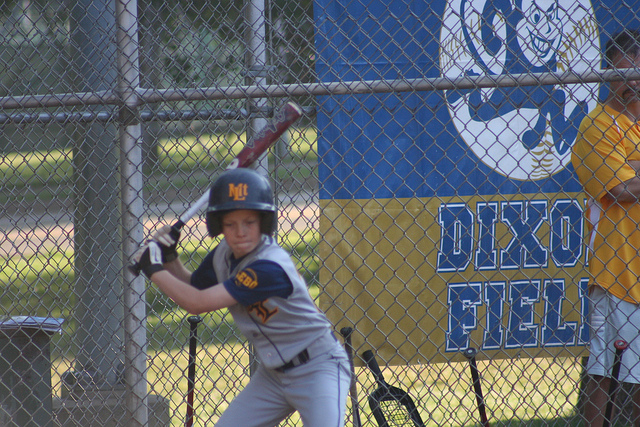Please identify all text content in this image. DIXO FIELI 